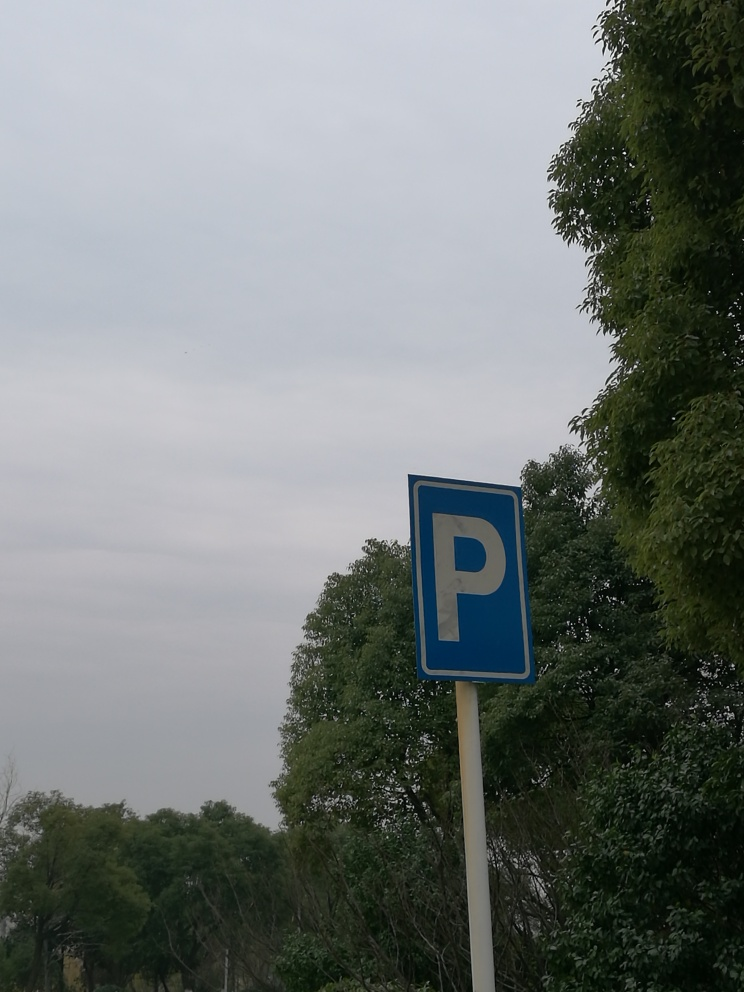What can you tell me about the parking restrictions indicated by this sign? The blue square sign featuring a white 'P' typically signifies the availability of a parking area. While this sign indicates general parking, further restrictions or regulations are not detailed and may require additional signage or local knowledge to understand fully. 